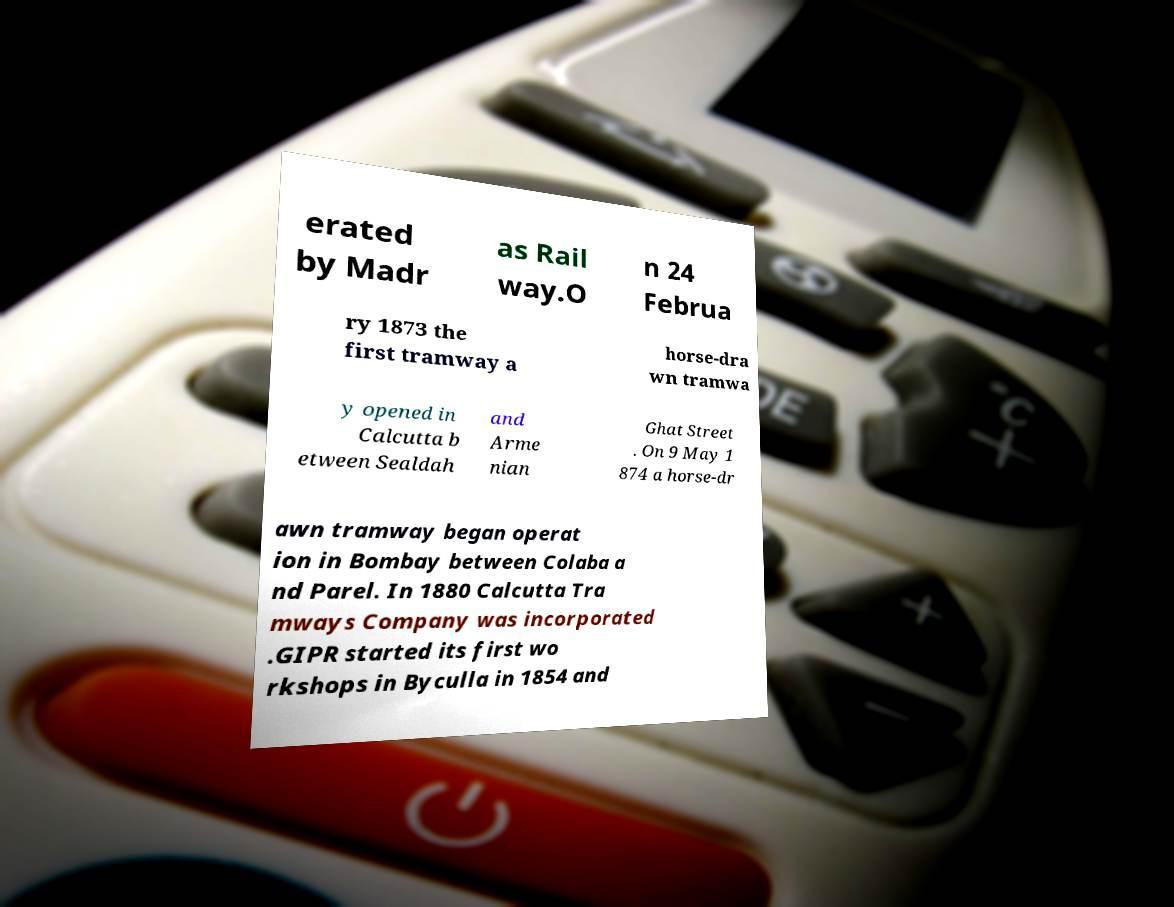I need the written content from this picture converted into text. Can you do that? erated by Madr as Rail way.O n 24 Februa ry 1873 the first tramway a horse-dra wn tramwa y opened in Calcutta b etween Sealdah and Arme nian Ghat Street . On 9 May 1 874 a horse-dr awn tramway began operat ion in Bombay between Colaba a nd Parel. In 1880 Calcutta Tra mways Company was incorporated .GIPR started its first wo rkshops in Byculla in 1854 and 